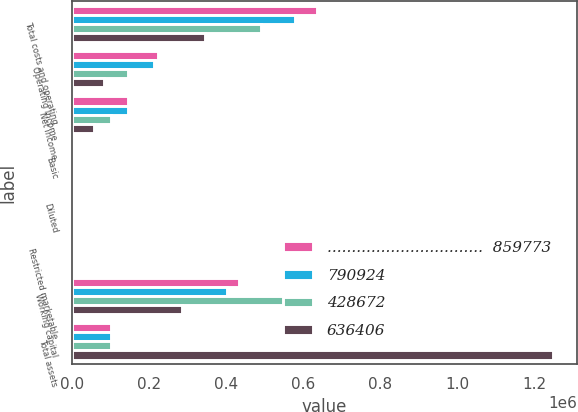Convert chart. <chart><loc_0><loc_0><loc_500><loc_500><stacked_bar_chart><ecel><fcel>Total costs and operating<fcel>Operating income<fcel>Net income<fcel>Basic<fcel>Diluted<fcel>Restricted marketable<fcel>Working capital<fcel>Total assets<nl><fcel>................................  859773<fcel>636293<fcel>223480<fcel>145913<fcel>0.85<fcel>0.78<fcel>638<fcel>433880<fcel>100967<nl><fcel>790924<fcel>578660<fcel>212264<fcel>145138<fcel>0.87<fcel>0.79<fcel>3613<fcel>401453<fcel>100967<nl><fcel>428672<fcel>491478<fcel>144928<fcel>100967<fcel>0.62<fcel>0.56<fcel>3613<fcel>606667<fcel>100967<nl><fcel>636406<fcel>345566<fcel>83106<fcel>57401<fcel>0.37<fcel>0.34<fcel>4207<fcel>285409<fcel>1.24793e+06<nl></chart> 